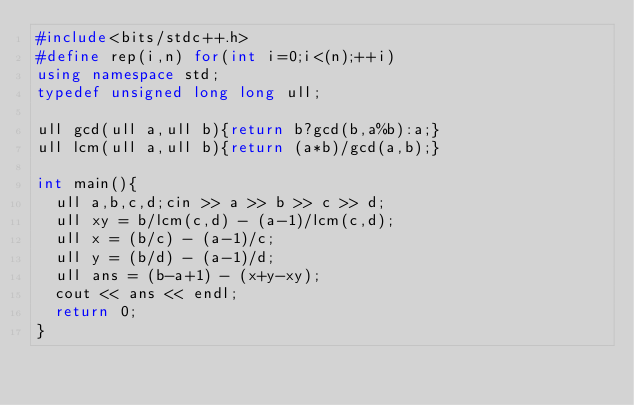Convert code to text. <code><loc_0><loc_0><loc_500><loc_500><_C++_>#include<bits/stdc++.h>
#define rep(i,n) for(int i=0;i<(n);++i)
using namespace std;
typedef unsigned long long ull;

ull gcd(ull a,ull b){return b?gcd(b,a%b):a;}
ull lcm(ull a,ull b){return (a*b)/gcd(a,b);}

int main(){
  ull a,b,c,d;cin >> a >> b >> c >> d;
  ull xy = b/lcm(c,d) - (a-1)/lcm(c,d);
  ull x = (b/c) - (a-1)/c;
  ull y = (b/d) - (a-1)/d;
  ull ans = (b-a+1) - (x+y-xy);
  cout << ans << endl;
  return 0;
}


</code> 